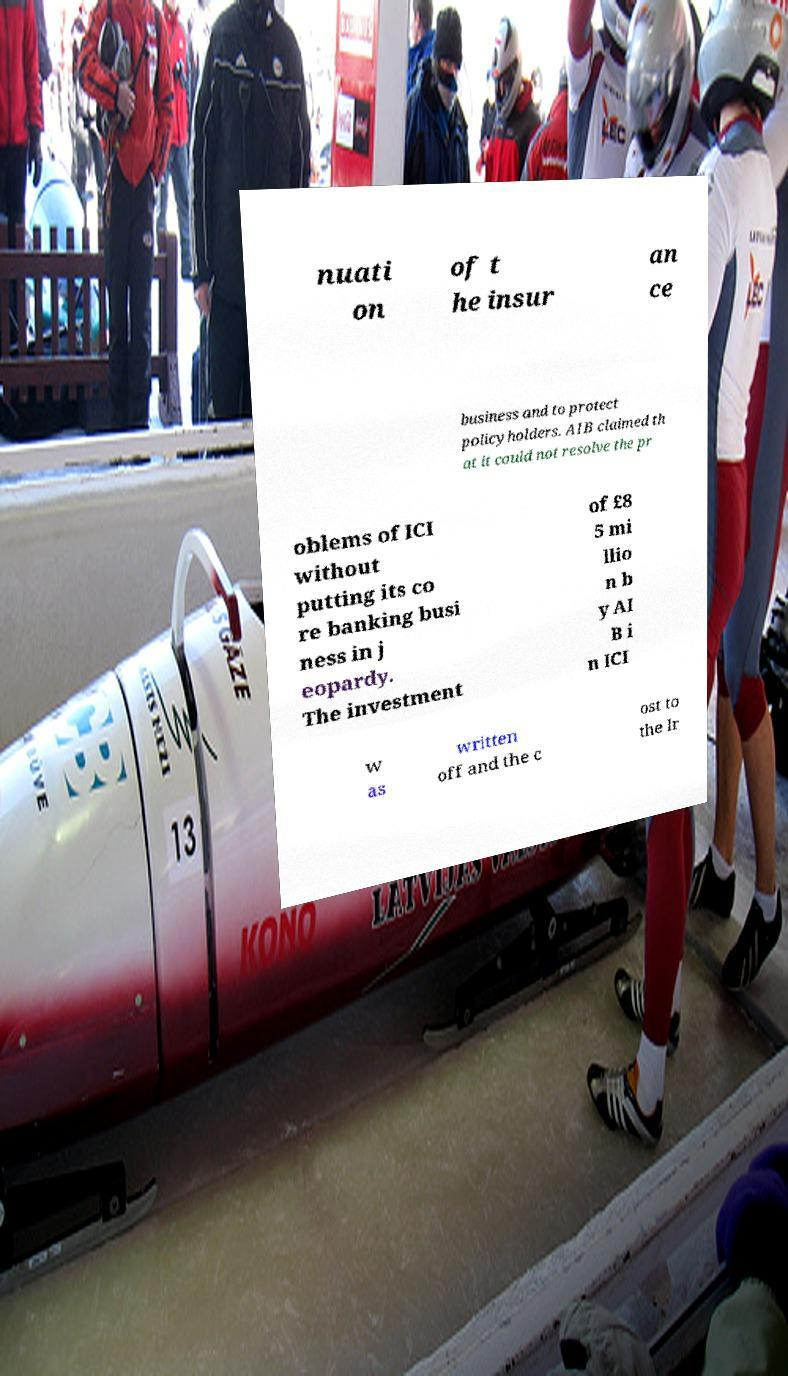There's text embedded in this image that I need extracted. Can you transcribe it verbatim? nuati on of t he insur an ce business and to protect policyholders. AIB claimed th at it could not resolve the pr oblems of ICI without putting its co re banking busi ness in j eopardy. The investment of £8 5 mi llio n b y AI B i n ICI w as written off and the c ost to the Ir 